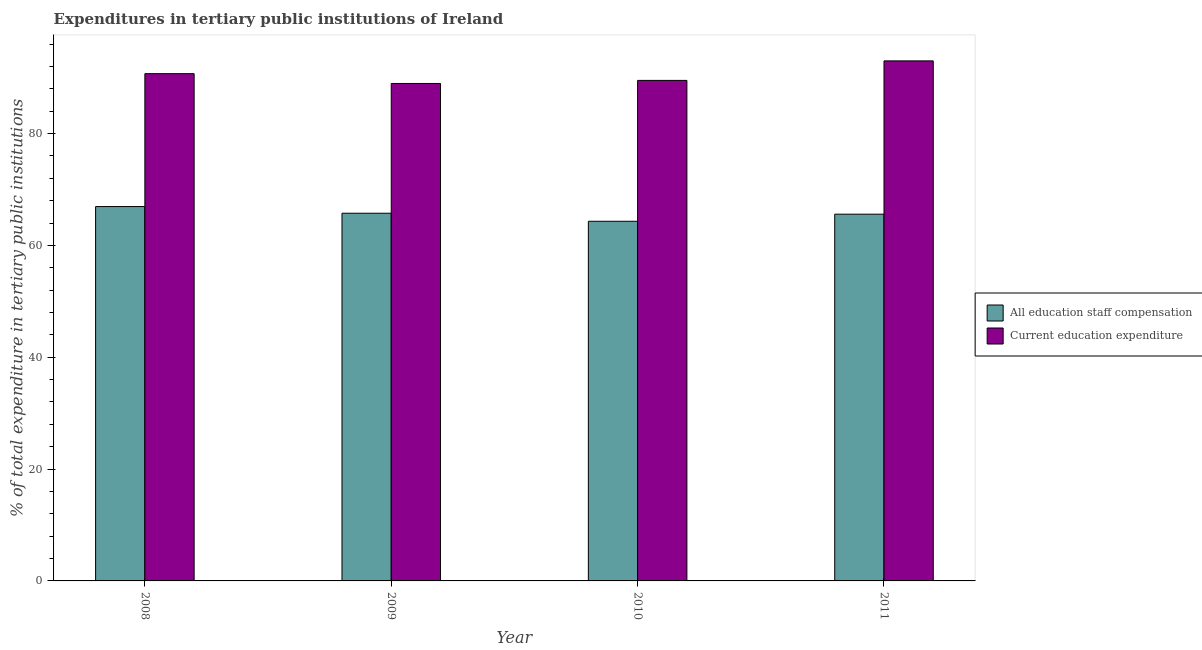How many different coloured bars are there?
Offer a very short reply. 2. How many groups of bars are there?
Make the answer very short. 4. Are the number of bars on each tick of the X-axis equal?
Your answer should be compact. Yes. How many bars are there on the 4th tick from the left?
Offer a very short reply. 2. How many bars are there on the 4th tick from the right?
Your response must be concise. 2. What is the expenditure in staff compensation in 2010?
Keep it short and to the point. 64.32. Across all years, what is the maximum expenditure in staff compensation?
Offer a very short reply. 66.95. Across all years, what is the minimum expenditure in education?
Your answer should be very brief. 88.96. In which year was the expenditure in staff compensation minimum?
Your answer should be compact. 2010. What is the total expenditure in education in the graph?
Your answer should be very brief. 362.19. What is the difference between the expenditure in staff compensation in 2010 and that in 2011?
Ensure brevity in your answer.  -1.27. What is the difference between the expenditure in staff compensation in 2008 and the expenditure in education in 2010?
Your answer should be compact. 2.63. What is the average expenditure in education per year?
Your answer should be compact. 90.55. In how many years, is the expenditure in staff compensation greater than 84 %?
Make the answer very short. 0. What is the ratio of the expenditure in staff compensation in 2008 to that in 2009?
Give a very brief answer. 1.02. Is the difference between the expenditure in education in 2008 and 2009 greater than the difference between the expenditure in staff compensation in 2008 and 2009?
Offer a very short reply. No. What is the difference between the highest and the second highest expenditure in staff compensation?
Your answer should be very brief. 1.19. What is the difference between the highest and the lowest expenditure in staff compensation?
Give a very brief answer. 2.63. What does the 2nd bar from the left in 2010 represents?
Your answer should be compact. Current education expenditure. What does the 1st bar from the right in 2009 represents?
Provide a short and direct response. Current education expenditure. How many bars are there?
Your answer should be very brief. 8. How many years are there in the graph?
Your answer should be very brief. 4. What is the difference between two consecutive major ticks on the Y-axis?
Keep it short and to the point. 20. Does the graph contain grids?
Provide a short and direct response. No. Where does the legend appear in the graph?
Make the answer very short. Center right. What is the title of the graph?
Offer a very short reply. Expenditures in tertiary public institutions of Ireland. What is the label or title of the X-axis?
Give a very brief answer. Year. What is the label or title of the Y-axis?
Keep it short and to the point. % of total expenditure in tertiary public institutions. What is the % of total expenditure in tertiary public institutions of All education staff compensation in 2008?
Offer a very short reply. 66.95. What is the % of total expenditure in tertiary public institutions of Current education expenditure in 2008?
Provide a short and direct response. 90.72. What is the % of total expenditure in tertiary public institutions of All education staff compensation in 2009?
Give a very brief answer. 65.76. What is the % of total expenditure in tertiary public institutions of Current education expenditure in 2009?
Offer a very short reply. 88.96. What is the % of total expenditure in tertiary public institutions of All education staff compensation in 2010?
Give a very brief answer. 64.32. What is the % of total expenditure in tertiary public institutions in Current education expenditure in 2010?
Ensure brevity in your answer.  89.51. What is the % of total expenditure in tertiary public institutions in All education staff compensation in 2011?
Your answer should be compact. 65.59. What is the % of total expenditure in tertiary public institutions in Current education expenditure in 2011?
Give a very brief answer. 93. Across all years, what is the maximum % of total expenditure in tertiary public institutions of All education staff compensation?
Your response must be concise. 66.95. Across all years, what is the maximum % of total expenditure in tertiary public institutions of Current education expenditure?
Make the answer very short. 93. Across all years, what is the minimum % of total expenditure in tertiary public institutions in All education staff compensation?
Your answer should be very brief. 64.32. Across all years, what is the minimum % of total expenditure in tertiary public institutions of Current education expenditure?
Keep it short and to the point. 88.96. What is the total % of total expenditure in tertiary public institutions of All education staff compensation in the graph?
Give a very brief answer. 262.61. What is the total % of total expenditure in tertiary public institutions in Current education expenditure in the graph?
Keep it short and to the point. 362.19. What is the difference between the % of total expenditure in tertiary public institutions in All education staff compensation in 2008 and that in 2009?
Your response must be concise. 1.19. What is the difference between the % of total expenditure in tertiary public institutions in Current education expenditure in 2008 and that in 2009?
Provide a short and direct response. 1.76. What is the difference between the % of total expenditure in tertiary public institutions of All education staff compensation in 2008 and that in 2010?
Your answer should be compact. 2.63. What is the difference between the % of total expenditure in tertiary public institutions in Current education expenditure in 2008 and that in 2010?
Your response must be concise. 1.21. What is the difference between the % of total expenditure in tertiary public institutions of All education staff compensation in 2008 and that in 2011?
Your answer should be very brief. 1.36. What is the difference between the % of total expenditure in tertiary public institutions in Current education expenditure in 2008 and that in 2011?
Provide a succinct answer. -2.29. What is the difference between the % of total expenditure in tertiary public institutions in All education staff compensation in 2009 and that in 2010?
Your answer should be very brief. 1.44. What is the difference between the % of total expenditure in tertiary public institutions of Current education expenditure in 2009 and that in 2010?
Your answer should be very brief. -0.55. What is the difference between the % of total expenditure in tertiary public institutions in All education staff compensation in 2009 and that in 2011?
Ensure brevity in your answer.  0.17. What is the difference between the % of total expenditure in tertiary public institutions in Current education expenditure in 2009 and that in 2011?
Your response must be concise. -4.04. What is the difference between the % of total expenditure in tertiary public institutions in All education staff compensation in 2010 and that in 2011?
Make the answer very short. -1.27. What is the difference between the % of total expenditure in tertiary public institutions in Current education expenditure in 2010 and that in 2011?
Your answer should be compact. -3.49. What is the difference between the % of total expenditure in tertiary public institutions of All education staff compensation in 2008 and the % of total expenditure in tertiary public institutions of Current education expenditure in 2009?
Your answer should be compact. -22.01. What is the difference between the % of total expenditure in tertiary public institutions of All education staff compensation in 2008 and the % of total expenditure in tertiary public institutions of Current education expenditure in 2010?
Ensure brevity in your answer.  -22.56. What is the difference between the % of total expenditure in tertiary public institutions in All education staff compensation in 2008 and the % of total expenditure in tertiary public institutions in Current education expenditure in 2011?
Your response must be concise. -26.06. What is the difference between the % of total expenditure in tertiary public institutions of All education staff compensation in 2009 and the % of total expenditure in tertiary public institutions of Current education expenditure in 2010?
Offer a terse response. -23.75. What is the difference between the % of total expenditure in tertiary public institutions of All education staff compensation in 2009 and the % of total expenditure in tertiary public institutions of Current education expenditure in 2011?
Make the answer very short. -27.25. What is the difference between the % of total expenditure in tertiary public institutions in All education staff compensation in 2010 and the % of total expenditure in tertiary public institutions in Current education expenditure in 2011?
Make the answer very short. -28.69. What is the average % of total expenditure in tertiary public institutions of All education staff compensation per year?
Provide a short and direct response. 65.65. What is the average % of total expenditure in tertiary public institutions in Current education expenditure per year?
Give a very brief answer. 90.55. In the year 2008, what is the difference between the % of total expenditure in tertiary public institutions in All education staff compensation and % of total expenditure in tertiary public institutions in Current education expenditure?
Your answer should be compact. -23.77. In the year 2009, what is the difference between the % of total expenditure in tertiary public institutions in All education staff compensation and % of total expenditure in tertiary public institutions in Current education expenditure?
Provide a succinct answer. -23.2. In the year 2010, what is the difference between the % of total expenditure in tertiary public institutions of All education staff compensation and % of total expenditure in tertiary public institutions of Current education expenditure?
Keep it short and to the point. -25.19. In the year 2011, what is the difference between the % of total expenditure in tertiary public institutions of All education staff compensation and % of total expenditure in tertiary public institutions of Current education expenditure?
Ensure brevity in your answer.  -27.42. What is the ratio of the % of total expenditure in tertiary public institutions in All education staff compensation in 2008 to that in 2009?
Offer a very short reply. 1.02. What is the ratio of the % of total expenditure in tertiary public institutions in Current education expenditure in 2008 to that in 2009?
Provide a succinct answer. 1.02. What is the ratio of the % of total expenditure in tertiary public institutions of All education staff compensation in 2008 to that in 2010?
Give a very brief answer. 1.04. What is the ratio of the % of total expenditure in tertiary public institutions in Current education expenditure in 2008 to that in 2010?
Your answer should be very brief. 1.01. What is the ratio of the % of total expenditure in tertiary public institutions in All education staff compensation in 2008 to that in 2011?
Your response must be concise. 1.02. What is the ratio of the % of total expenditure in tertiary public institutions in Current education expenditure in 2008 to that in 2011?
Offer a terse response. 0.98. What is the ratio of the % of total expenditure in tertiary public institutions in All education staff compensation in 2009 to that in 2010?
Give a very brief answer. 1.02. What is the ratio of the % of total expenditure in tertiary public institutions of All education staff compensation in 2009 to that in 2011?
Your response must be concise. 1. What is the ratio of the % of total expenditure in tertiary public institutions of Current education expenditure in 2009 to that in 2011?
Provide a short and direct response. 0.96. What is the ratio of the % of total expenditure in tertiary public institutions of All education staff compensation in 2010 to that in 2011?
Offer a very short reply. 0.98. What is the ratio of the % of total expenditure in tertiary public institutions of Current education expenditure in 2010 to that in 2011?
Provide a short and direct response. 0.96. What is the difference between the highest and the second highest % of total expenditure in tertiary public institutions of All education staff compensation?
Your answer should be compact. 1.19. What is the difference between the highest and the second highest % of total expenditure in tertiary public institutions of Current education expenditure?
Keep it short and to the point. 2.29. What is the difference between the highest and the lowest % of total expenditure in tertiary public institutions in All education staff compensation?
Keep it short and to the point. 2.63. What is the difference between the highest and the lowest % of total expenditure in tertiary public institutions of Current education expenditure?
Your response must be concise. 4.04. 